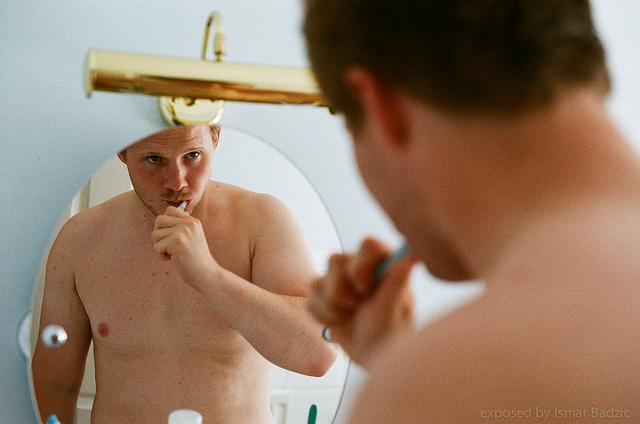What is this activity good for?

Choices:
A) building muscles
B) nutrition
C) gum health
D) mental health gum health 